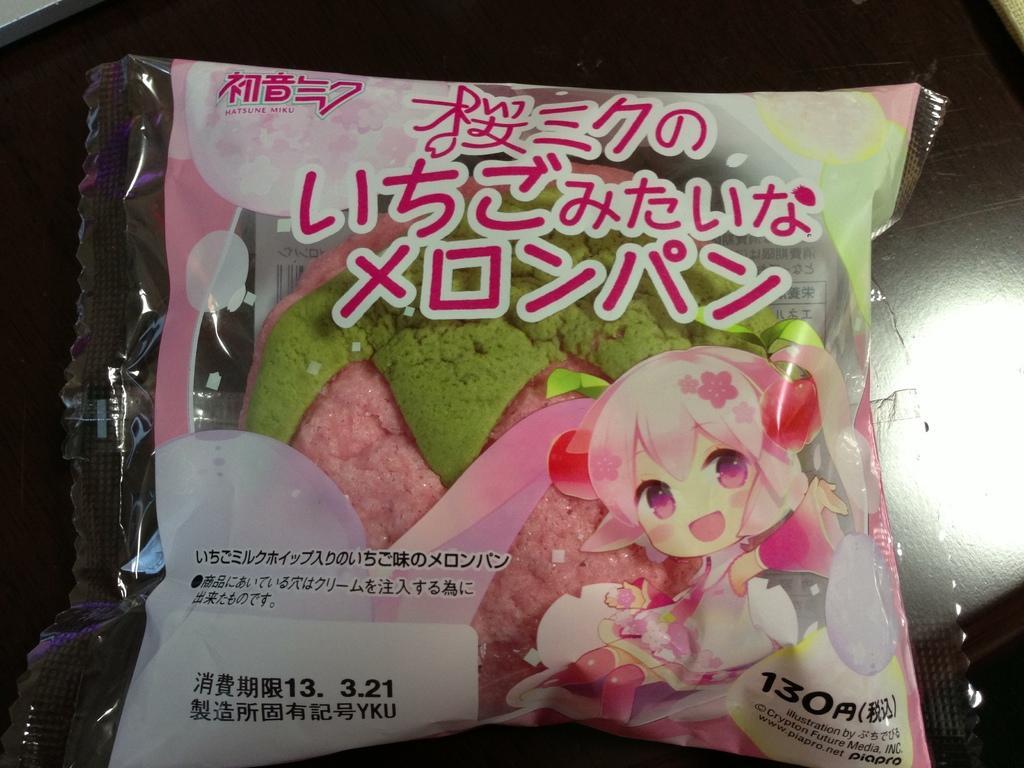Could you give a brief overview of what you see in this image? In this image I can see a packet on a black surface. On this packet there is some text and a cartoon image. Inside the packet, I can see green and pink color objects. 